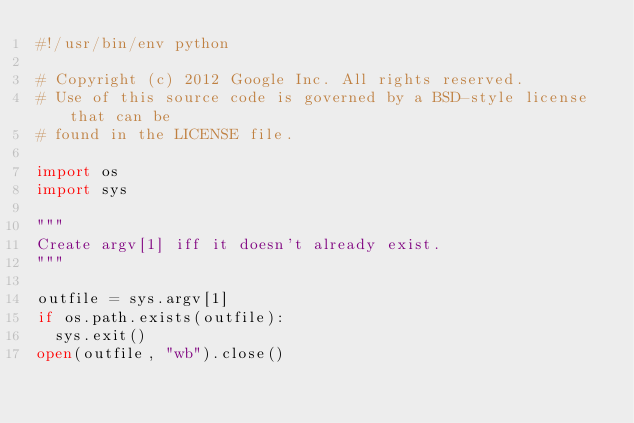<code> <loc_0><loc_0><loc_500><loc_500><_Python_>#!/usr/bin/env python

# Copyright (c) 2012 Google Inc. All rights reserved.
# Use of this source code is governed by a BSD-style license that can be
# found in the LICENSE file.

import os
import sys

"""
Create argv[1] iff it doesn't already exist.
"""

outfile = sys.argv[1]
if os.path.exists(outfile):
  sys.exit()
open(outfile, "wb").close()
</code> 